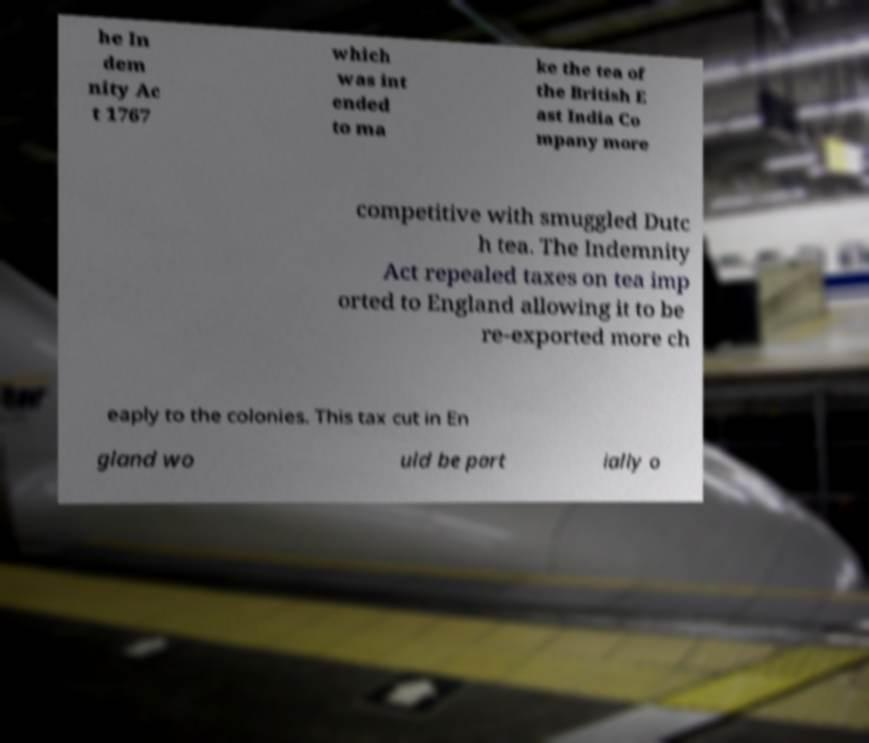Could you extract and type out the text from this image? he In dem nity Ac t 1767 which was int ended to ma ke the tea of the British E ast India Co mpany more competitive with smuggled Dutc h tea. The Indemnity Act repealed taxes on tea imp orted to England allowing it to be re-exported more ch eaply to the colonies. This tax cut in En gland wo uld be part ially o 